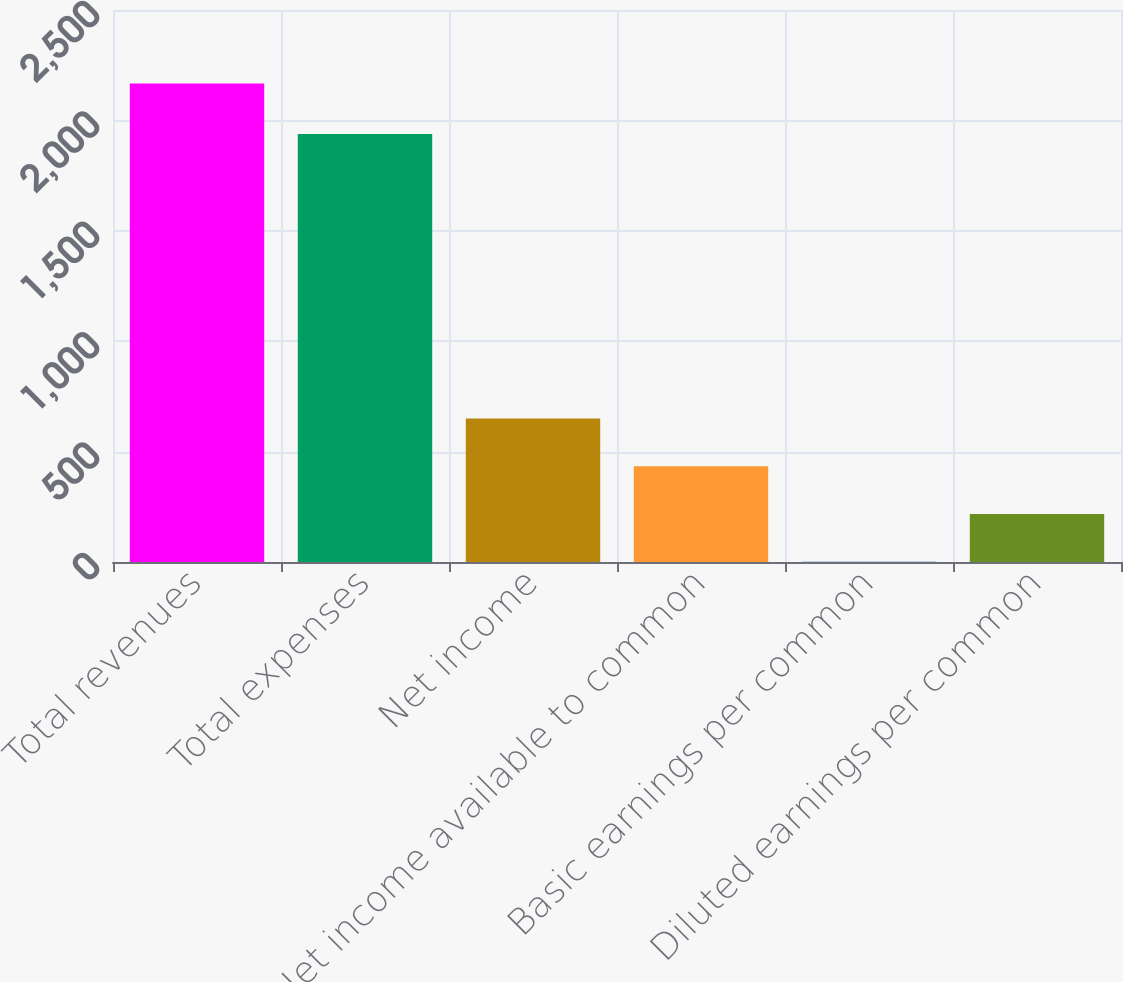Convert chart to OTSL. <chart><loc_0><loc_0><loc_500><loc_500><bar_chart><fcel>Total revenues<fcel>Total expenses<fcel>Net income<fcel>Net income available to common<fcel>Basic earnings per common<fcel>Diluted earnings per common<nl><fcel>2166.7<fcel>1938.5<fcel>650.44<fcel>433.83<fcel>0.61<fcel>217.22<nl></chart> 